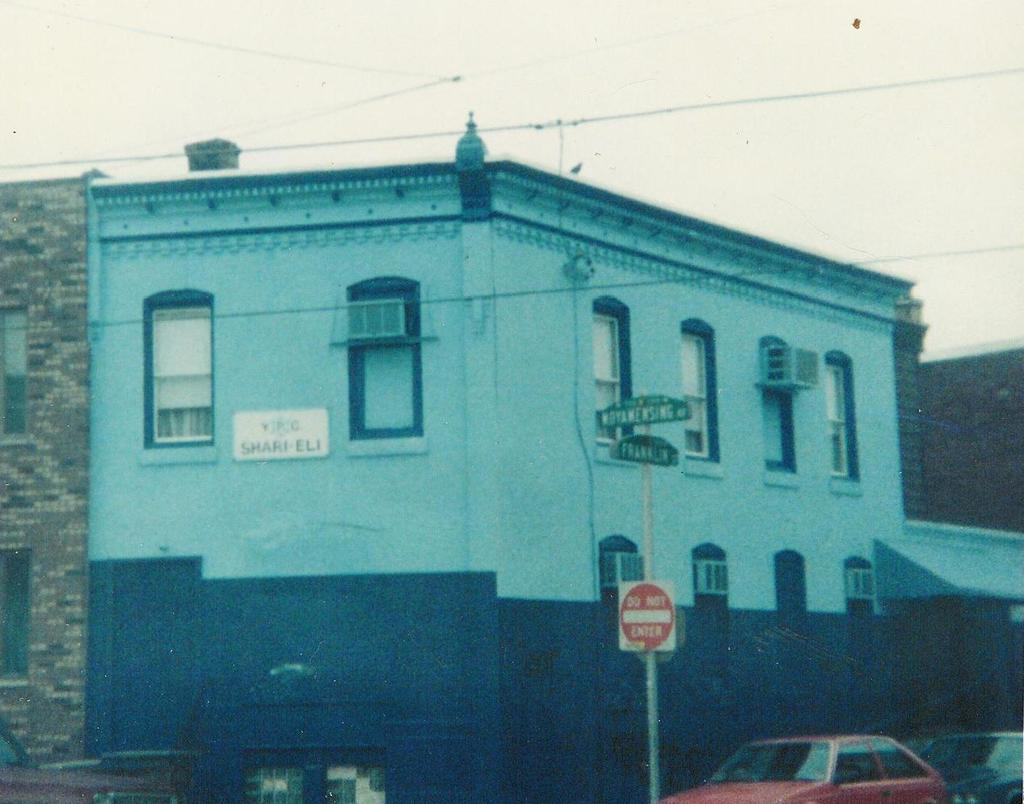<image>
Share a concise interpretation of the image provided. A do not enter sign on a road near a building. 